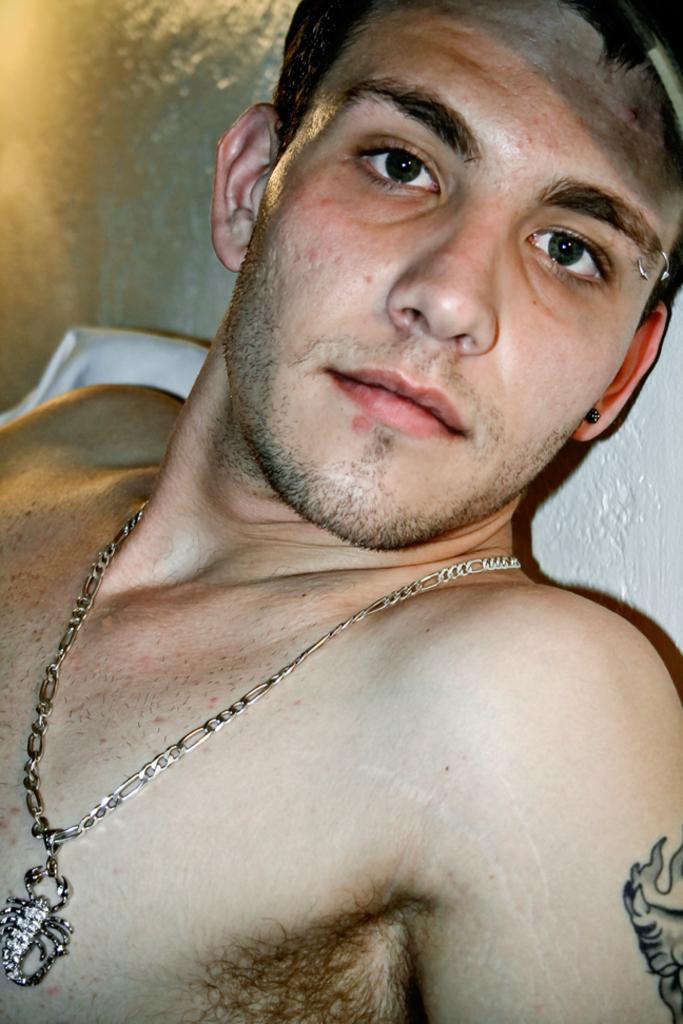Please provide a concise description of this image. In this image there is a person truncated, the person is wearing a chain, there is an object truncated towards the left of the image, at the background of the image there is a wall truncated. 